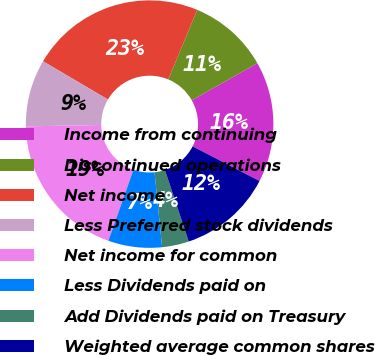Convert chart. <chart><loc_0><loc_0><loc_500><loc_500><pie_chart><fcel>Income from continuing<fcel>Discontinued operations<fcel>Net income<fcel>Less Preferred stock dividends<fcel>Net income for common<fcel>Less Dividends paid on<fcel>Add Dividends paid on Treasury<fcel>Weighted average common shares<nl><fcel>15.79%<fcel>10.53%<fcel>22.81%<fcel>8.77%<fcel>19.3%<fcel>7.02%<fcel>3.51%<fcel>12.28%<nl></chart> 